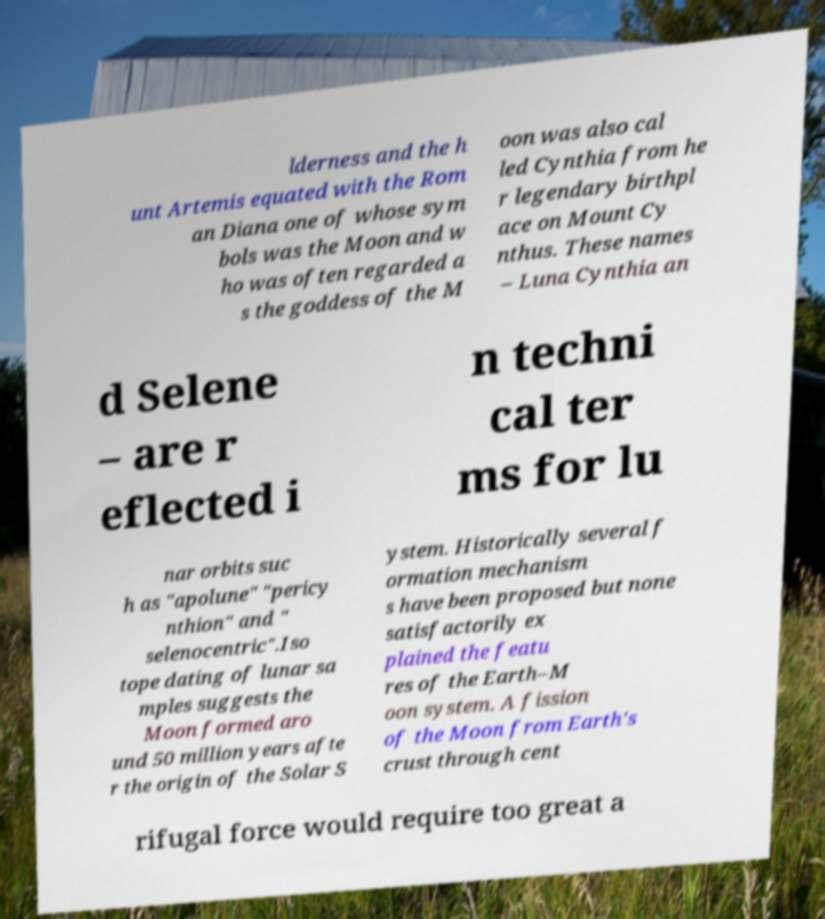Please identify and transcribe the text found in this image. lderness and the h unt Artemis equated with the Rom an Diana one of whose sym bols was the Moon and w ho was often regarded a s the goddess of the M oon was also cal led Cynthia from he r legendary birthpl ace on Mount Cy nthus. These names – Luna Cynthia an d Selene – are r eflected i n techni cal ter ms for lu nar orbits suc h as "apolune" "pericy nthion" and " selenocentric".Iso tope dating of lunar sa mples suggests the Moon formed aro und 50 million years afte r the origin of the Solar S ystem. Historically several f ormation mechanism s have been proposed but none satisfactorily ex plained the featu res of the Earth–M oon system. A fission of the Moon from Earth's crust through cent rifugal force would require too great a 